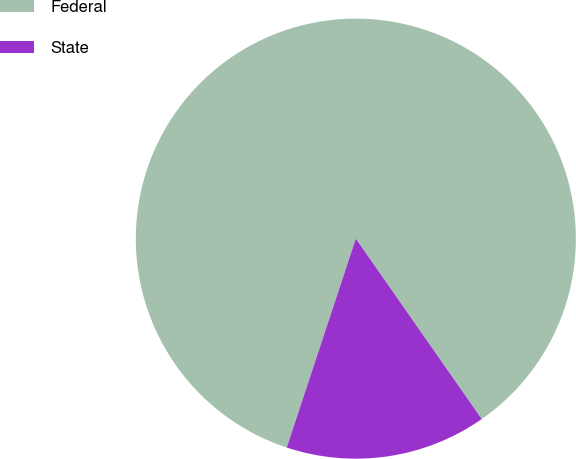Convert chart. <chart><loc_0><loc_0><loc_500><loc_500><pie_chart><fcel>Federal<fcel>State<nl><fcel>85.22%<fcel>14.78%<nl></chart> 